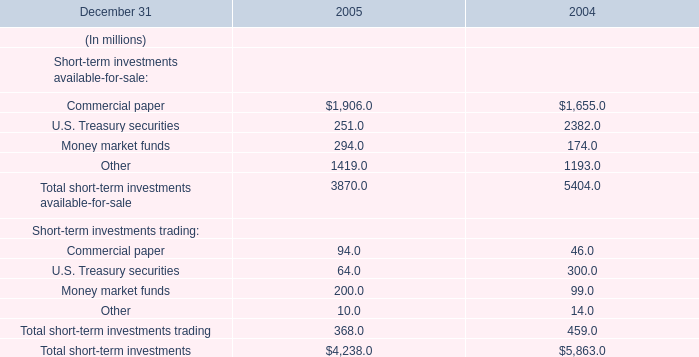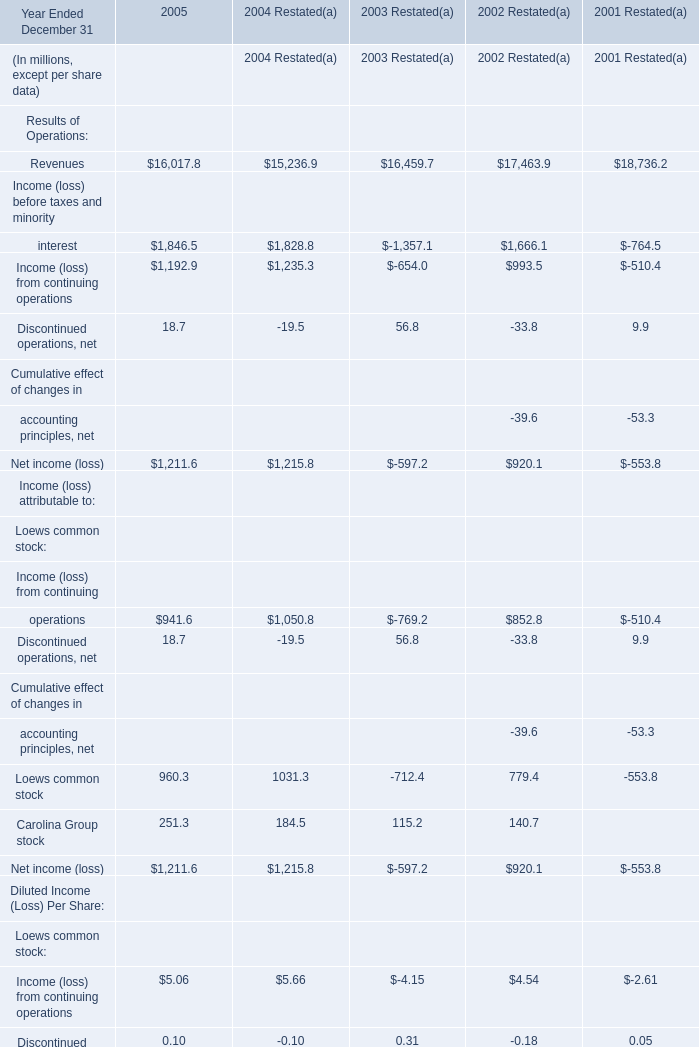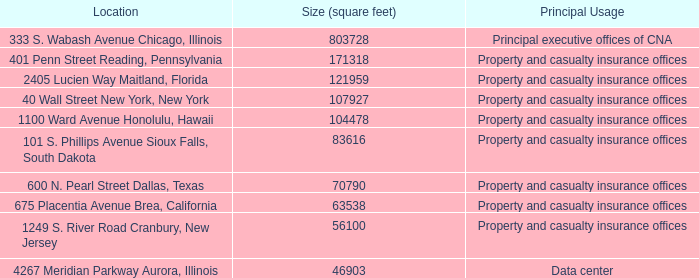what is diamond offshore's total rig count? 
Computations: (47 + 32)
Answer: 79.0. 